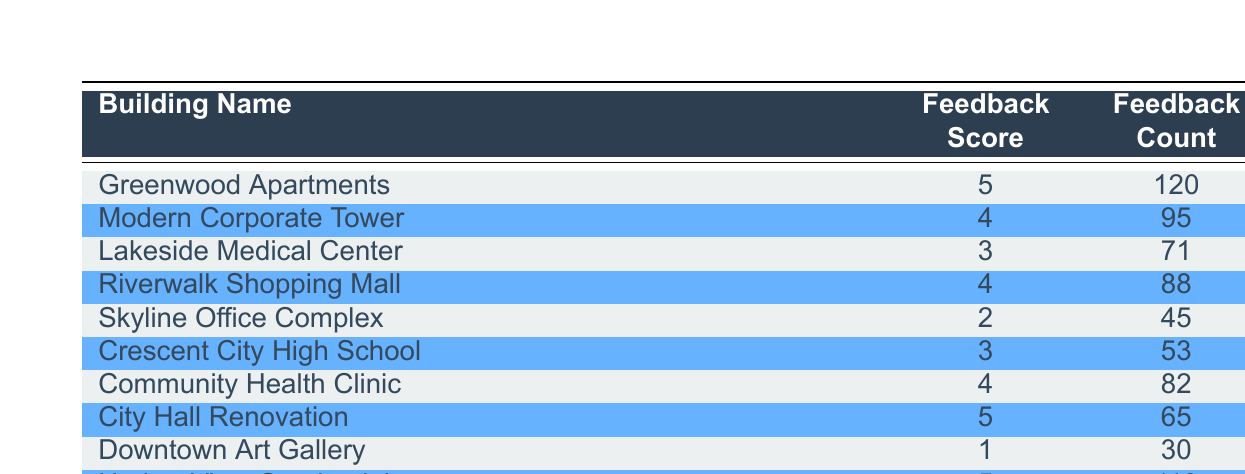What is the feedback score for the Harbor View Condominiums? The table lists the feedback score for each building. For the Harbor View Condominiums, the feedback score is directly provided in the second column of the corresponding row.
Answer: 5 How many feedback counts does the Community Health Clinic have? To find this, we check the row for the Community Health Clinic in the table. The feedback count is listed in the third column of that row.
Answer: 82 Which building received the lowest feedback score? By scanning through the feedback scores in the second column, the lowest score is 1, which corresponds to the Downtown Art Gallery.
Answer: Downtown Art Gallery What is the total feedback count for buildings that received a score of 4? We need to identify all buildings with a score of 4 and sum their feedback counts. The buildings are: Modern Corporate Tower (95), Riverwalk Shopping Mall (88), and Community Health Clinic (82). The total is 95 + 88 + 82 = 265.
Answer: 265 Is it true that the Lakeside Medical Center has more feedback counts than the Skyline Office Complex? We compare the feedback counts of both buildings: Lakeside Medical Center has 71, while Skyline Office Complex has 45. Since 71 is greater than 45, the statement is true.
Answer: Yes What is the average feedback score across all buildings? To calculate this, sum the feedback scores of all buildings: (5 + 4 + 3 + 4 + 2 + 3 + 4 + 5 + 1 + 5) = 36. There are 10 buildings, so the average score is 36/10 = 3.6.
Answer: 3.6 How many buildings have received a feedback score of 5? We look for rows with a feedback score of 5. In the table, Greenwood Apartments, City Hall Renovation, and Harbor View Condominiums all have this score. Counting these gives us 3 buildings.
Answer: 3 Which building has the highest feedback count among buildings with a score of 4? We identify the buildings with a score of 4, which are Modern Corporate Tower (95), Riverwalk Shopping Mall (88), and Community Health Clinic (82). The highest feedback count is from Modern Corporate Tower.
Answer: Modern Corporate Tower 